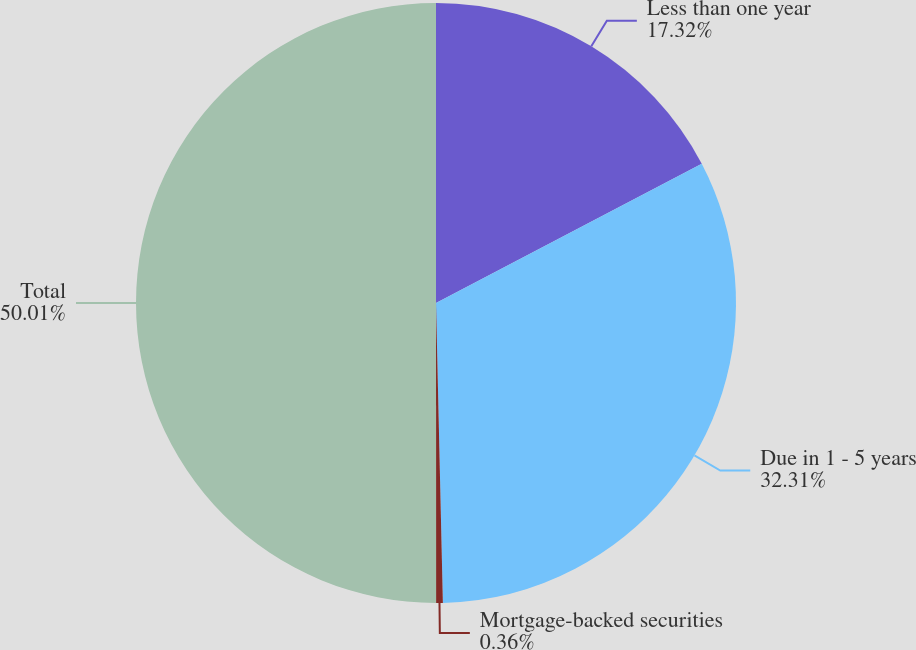Convert chart. <chart><loc_0><loc_0><loc_500><loc_500><pie_chart><fcel>Less than one year<fcel>Due in 1 - 5 years<fcel>Mortgage-backed securities<fcel>Total<nl><fcel>17.32%<fcel>32.31%<fcel>0.36%<fcel>50.0%<nl></chart> 